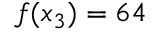<formula> <loc_0><loc_0><loc_500><loc_500>f ( x _ { 3 } ) = 6 4</formula> 